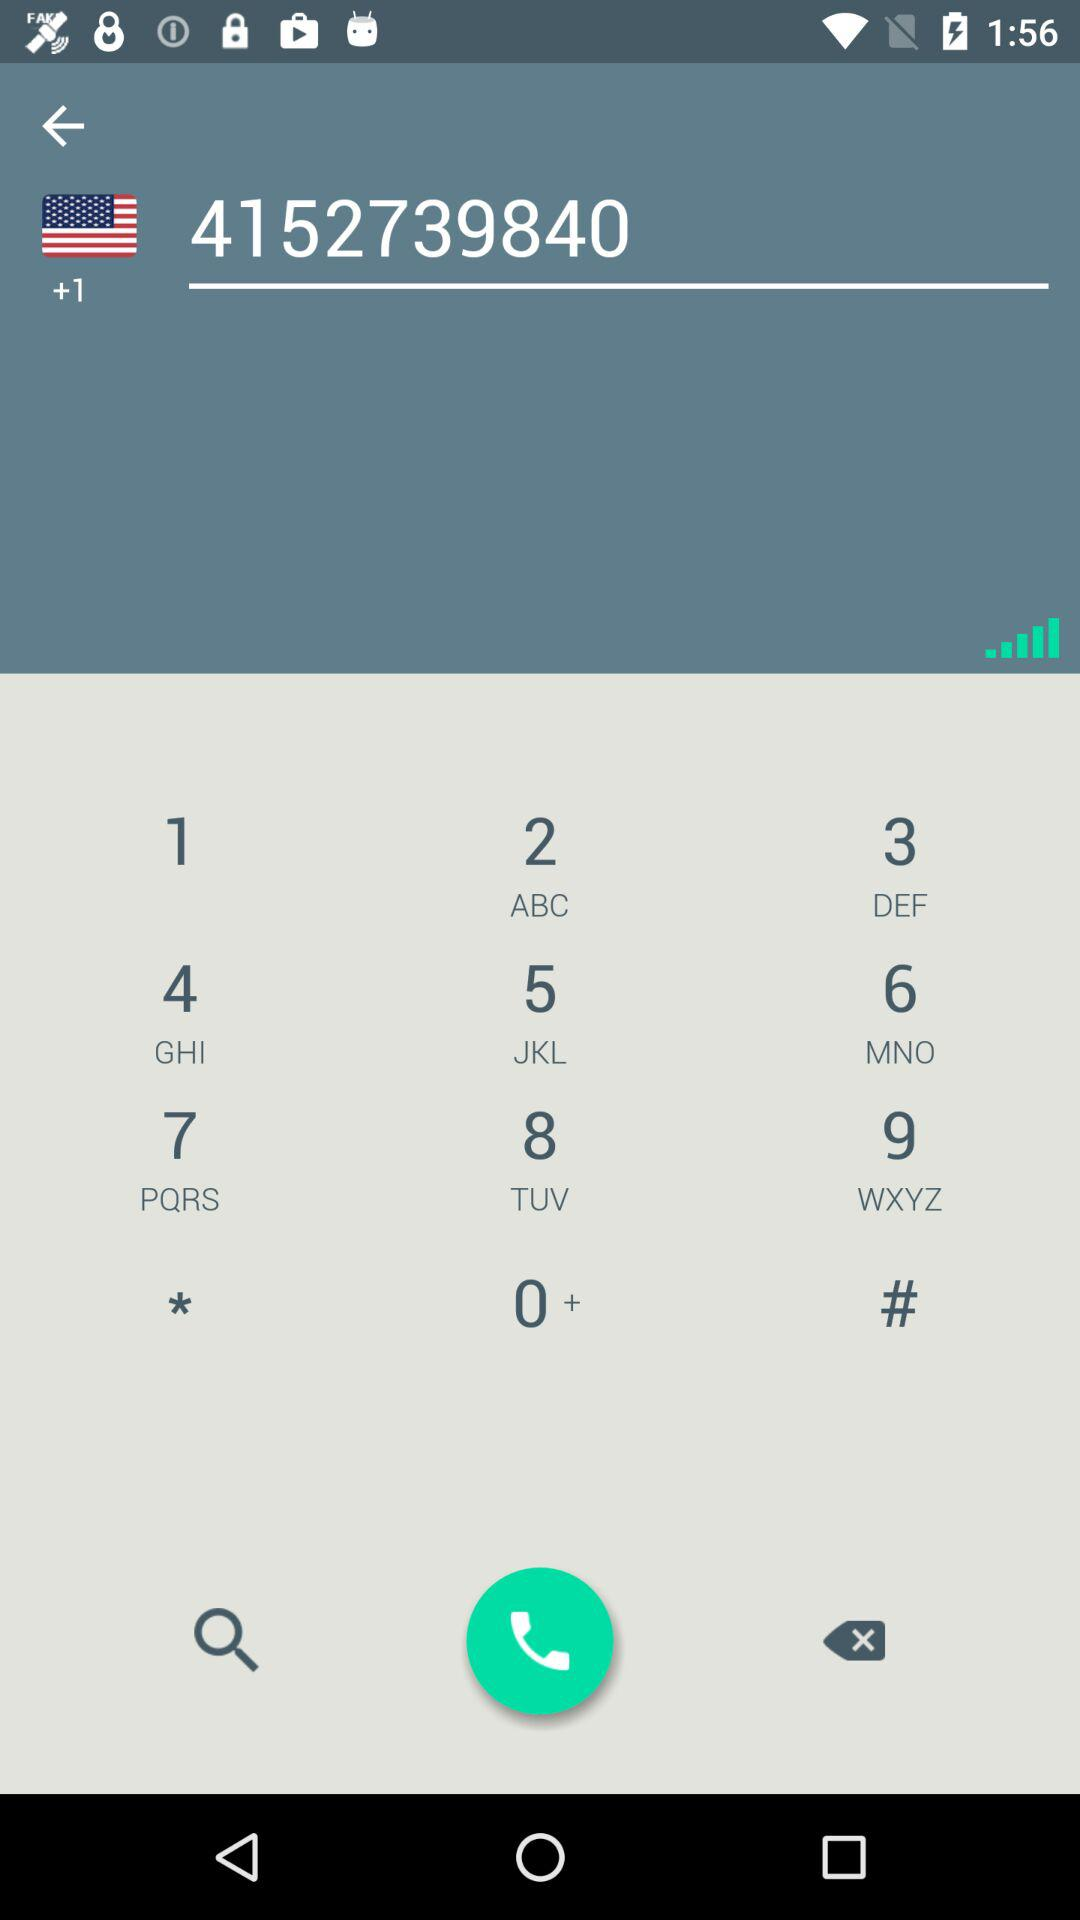What is the dialed phone number? The dialed number is +14152739840. 